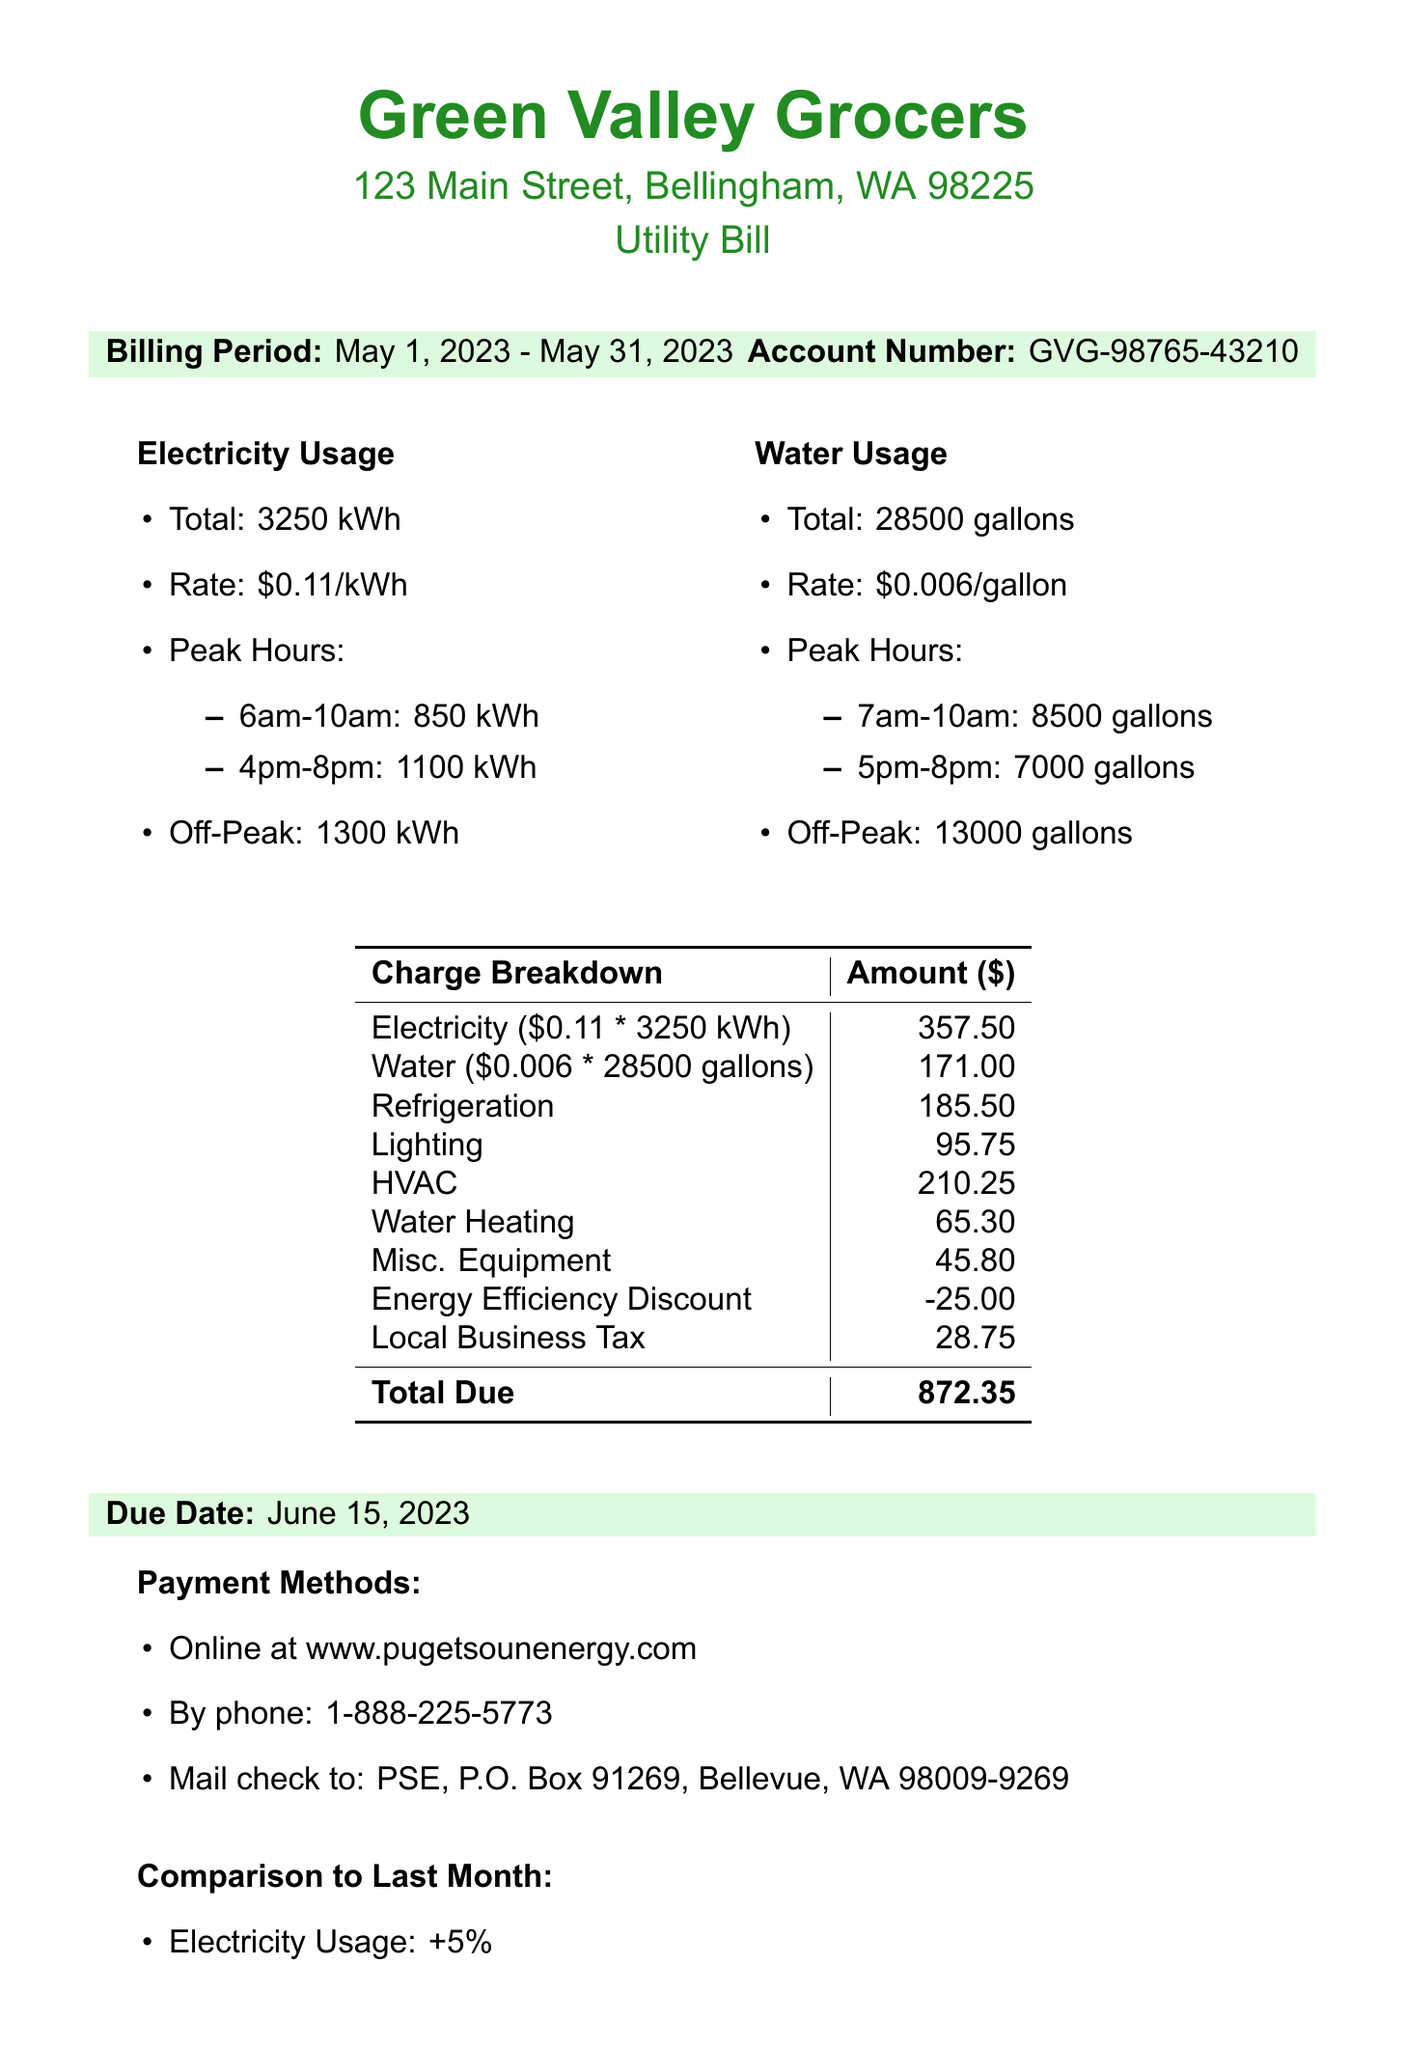What is the billing period? The billing period is mentioned in the document covering from May 1, 2023 to May 31, 2023.
Answer: May 1, 2023 - May 31, 2023 What is the total electricity usage in kWh? The total electricity usage is stated clearly in the document as 3250 kWh.
Answer: 3250 kWh What is the due date for this bill? The due date for the bill is specified in the document as June 15, 2023.
Answer: June 15, 2023 What is the total amount due? The total amount due is presented in the breakdown section as $872.35.
Answer: $872.35 How much water is used during peak hours? The peak hour water usage sums the amounts listed for the different time slots, totaling 15500 gallons.
Answer: 15500 gallons What discount is applied to the bill? The energy efficiency discount is indicated in the document as -$25.00.
Answer: -25.00 What is the rate of electricity per kWh? The rate for electricity is stated in the document as $0.11 per kWh.
Answer: $0.11 What percentage did the electricity usage change compared to last month? The electricity usage change is marked as +5% in the comparison section.
Answer: +5% What is the charge for refrigeration? The refrigeration charge is specified as $185.50 in the charge breakdown.
Answer: $185.50 